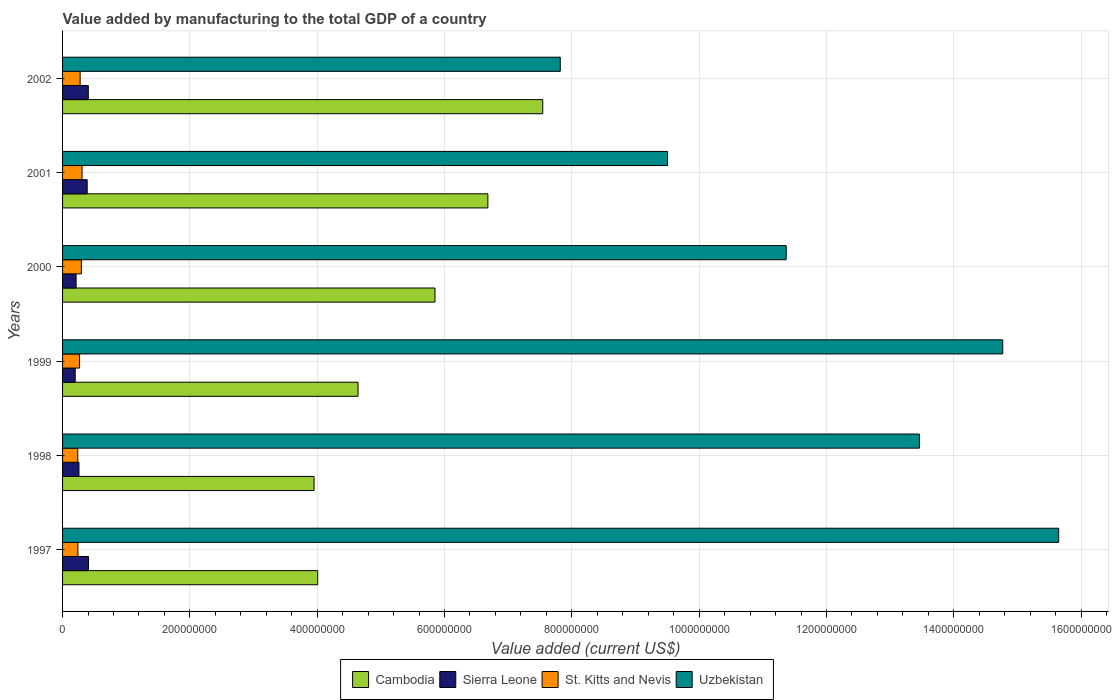How many different coloured bars are there?
Ensure brevity in your answer.  4. Are the number of bars per tick equal to the number of legend labels?
Provide a short and direct response. Yes. How many bars are there on the 4th tick from the top?
Make the answer very short. 4. What is the value added by manufacturing to the total GDP in St. Kitts and Nevis in 2002?
Make the answer very short. 2.76e+07. Across all years, what is the maximum value added by manufacturing to the total GDP in Uzbekistan?
Give a very brief answer. 1.56e+09. Across all years, what is the minimum value added by manufacturing to the total GDP in Uzbekistan?
Offer a very short reply. 7.82e+08. In which year was the value added by manufacturing to the total GDP in Uzbekistan maximum?
Make the answer very short. 1997. What is the total value added by manufacturing to the total GDP in Sierra Leone in the graph?
Provide a short and direct response. 1.87e+08. What is the difference between the value added by manufacturing to the total GDP in Cambodia in 2001 and that in 2002?
Offer a terse response. -8.62e+07. What is the difference between the value added by manufacturing to the total GDP in Sierra Leone in 1999 and the value added by manufacturing to the total GDP in Cambodia in 2001?
Give a very brief answer. -6.48e+08. What is the average value added by manufacturing to the total GDP in Uzbekistan per year?
Provide a short and direct response. 1.21e+09. In the year 1997, what is the difference between the value added by manufacturing to the total GDP in St. Kitts and Nevis and value added by manufacturing to the total GDP in Cambodia?
Your response must be concise. -3.77e+08. In how many years, is the value added by manufacturing to the total GDP in Cambodia greater than 1400000000 US$?
Provide a short and direct response. 0. What is the ratio of the value added by manufacturing to the total GDP in Sierra Leone in 1998 to that in 2002?
Make the answer very short. 0.64. What is the difference between the highest and the second highest value added by manufacturing to the total GDP in Cambodia?
Offer a terse response. 8.62e+07. What is the difference between the highest and the lowest value added by manufacturing to the total GDP in Cambodia?
Your answer should be very brief. 3.59e+08. What does the 1st bar from the top in 1998 represents?
Your answer should be compact. Uzbekistan. What does the 4th bar from the bottom in 1998 represents?
Keep it short and to the point. Uzbekistan. Is it the case that in every year, the sum of the value added by manufacturing to the total GDP in Sierra Leone and value added by manufacturing to the total GDP in Uzbekistan is greater than the value added by manufacturing to the total GDP in St. Kitts and Nevis?
Your response must be concise. Yes. How many bars are there?
Your answer should be compact. 24. Are all the bars in the graph horizontal?
Ensure brevity in your answer.  Yes. What is the difference between two consecutive major ticks on the X-axis?
Your answer should be compact. 2.00e+08. Are the values on the major ticks of X-axis written in scientific E-notation?
Provide a succinct answer. No. Does the graph contain any zero values?
Your answer should be compact. No. Does the graph contain grids?
Provide a short and direct response. Yes. How are the legend labels stacked?
Ensure brevity in your answer.  Horizontal. What is the title of the graph?
Ensure brevity in your answer.  Value added by manufacturing to the total GDP of a country. What is the label or title of the X-axis?
Your response must be concise. Value added (current US$). What is the label or title of the Y-axis?
Your answer should be very brief. Years. What is the Value added (current US$) in Cambodia in 1997?
Provide a short and direct response. 4.01e+08. What is the Value added (current US$) of Sierra Leone in 1997?
Keep it short and to the point. 4.07e+07. What is the Value added (current US$) of St. Kitts and Nevis in 1997?
Provide a succinct answer. 2.41e+07. What is the Value added (current US$) in Uzbekistan in 1997?
Provide a short and direct response. 1.56e+09. What is the Value added (current US$) in Cambodia in 1998?
Provide a succinct answer. 3.95e+08. What is the Value added (current US$) in Sierra Leone in 1998?
Your answer should be very brief. 2.58e+07. What is the Value added (current US$) in St. Kitts and Nevis in 1998?
Keep it short and to the point. 2.38e+07. What is the Value added (current US$) in Uzbekistan in 1998?
Keep it short and to the point. 1.35e+09. What is the Value added (current US$) of Cambodia in 1999?
Offer a very short reply. 4.64e+08. What is the Value added (current US$) in Sierra Leone in 1999?
Offer a very short reply. 1.99e+07. What is the Value added (current US$) in St. Kitts and Nevis in 1999?
Your answer should be compact. 2.67e+07. What is the Value added (current US$) of Uzbekistan in 1999?
Make the answer very short. 1.48e+09. What is the Value added (current US$) in Cambodia in 2000?
Your answer should be very brief. 5.85e+08. What is the Value added (current US$) of Sierra Leone in 2000?
Provide a short and direct response. 2.13e+07. What is the Value added (current US$) of St. Kitts and Nevis in 2000?
Provide a succinct answer. 2.95e+07. What is the Value added (current US$) of Uzbekistan in 2000?
Your response must be concise. 1.14e+09. What is the Value added (current US$) in Cambodia in 2001?
Your answer should be compact. 6.68e+08. What is the Value added (current US$) of Sierra Leone in 2001?
Ensure brevity in your answer.  3.87e+07. What is the Value added (current US$) in St. Kitts and Nevis in 2001?
Ensure brevity in your answer.  3.06e+07. What is the Value added (current US$) of Uzbekistan in 2001?
Offer a terse response. 9.50e+08. What is the Value added (current US$) of Cambodia in 2002?
Keep it short and to the point. 7.54e+08. What is the Value added (current US$) of Sierra Leone in 2002?
Your response must be concise. 4.04e+07. What is the Value added (current US$) in St. Kitts and Nevis in 2002?
Give a very brief answer. 2.76e+07. What is the Value added (current US$) of Uzbekistan in 2002?
Offer a very short reply. 7.82e+08. Across all years, what is the maximum Value added (current US$) of Cambodia?
Offer a very short reply. 7.54e+08. Across all years, what is the maximum Value added (current US$) in Sierra Leone?
Keep it short and to the point. 4.07e+07. Across all years, what is the maximum Value added (current US$) in St. Kitts and Nevis?
Keep it short and to the point. 3.06e+07. Across all years, what is the maximum Value added (current US$) in Uzbekistan?
Offer a very short reply. 1.56e+09. Across all years, what is the minimum Value added (current US$) of Cambodia?
Your answer should be compact. 3.95e+08. Across all years, what is the minimum Value added (current US$) of Sierra Leone?
Your answer should be very brief. 1.99e+07. Across all years, what is the minimum Value added (current US$) in St. Kitts and Nevis?
Give a very brief answer. 2.38e+07. Across all years, what is the minimum Value added (current US$) in Uzbekistan?
Make the answer very short. 7.82e+08. What is the total Value added (current US$) of Cambodia in the graph?
Your response must be concise. 3.27e+09. What is the total Value added (current US$) of Sierra Leone in the graph?
Ensure brevity in your answer.  1.87e+08. What is the total Value added (current US$) in St. Kitts and Nevis in the graph?
Keep it short and to the point. 1.62e+08. What is the total Value added (current US$) of Uzbekistan in the graph?
Offer a terse response. 7.26e+09. What is the difference between the Value added (current US$) in Cambodia in 1997 and that in 1998?
Offer a very short reply. 5.71e+06. What is the difference between the Value added (current US$) in Sierra Leone in 1997 and that in 1998?
Your answer should be compact. 1.50e+07. What is the difference between the Value added (current US$) in St. Kitts and Nevis in 1997 and that in 1998?
Keep it short and to the point. 2.63e+05. What is the difference between the Value added (current US$) of Uzbekistan in 1997 and that in 1998?
Give a very brief answer. 2.19e+08. What is the difference between the Value added (current US$) of Cambodia in 1997 and that in 1999?
Offer a terse response. -6.34e+07. What is the difference between the Value added (current US$) in Sierra Leone in 1997 and that in 1999?
Provide a succinct answer. 2.09e+07. What is the difference between the Value added (current US$) in St. Kitts and Nevis in 1997 and that in 1999?
Offer a very short reply. -2.59e+06. What is the difference between the Value added (current US$) in Uzbekistan in 1997 and that in 1999?
Your answer should be very brief. 8.79e+07. What is the difference between the Value added (current US$) of Cambodia in 1997 and that in 2000?
Keep it short and to the point. -1.84e+08. What is the difference between the Value added (current US$) of Sierra Leone in 1997 and that in 2000?
Your answer should be very brief. 1.95e+07. What is the difference between the Value added (current US$) in St. Kitts and Nevis in 1997 and that in 2000?
Provide a short and direct response. -5.41e+06. What is the difference between the Value added (current US$) in Uzbekistan in 1997 and that in 2000?
Keep it short and to the point. 4.28e+08. What is the difference between the Value added (current US$) in Cambodia in 1997 and that in 2001?
Your response must be concise. -2.67e+08. What is the difference between the Value added (current US$) of Sierra Leone in 1997 and that in 2001?
Keep it short and to the point. 2.05e+06. What is the difference between the Value added (current US$) of St. Kitts and Nevis in 1997 and that in 2001?
Give a very brief answer. -6.47e+06. What is the difference between the Value added (current US$) of Uzbekistan in 1997 and that in 2001?
Give a very brief answer. 6.14e+08. What is the difference between the Value added (current US$) in Cambodia in 1997 and that in 2002?
Offer a very short reply. -3.54e+08. What is the difference between the Value added (current US$) of Sierra Leone in 1997 and that in 2002?
Keep it short and to the point. 3.05e+05. What is the difference between the Value added (current US$) of St. Kitts and Nevis in 1997 and that in 2002?
Make the answer very short. -3.47e+06. What is the difference between the Value added (current US$) of Uzbekistan in 1997 and that in 2002?
Provide a succinct answer. 7.83e+08. What is the difference between the Value added (current US$) in Cambodia in 1998 and that in 1999?
Ensure brevity in your answer.  -6.91e+07. What is the difference between the Value added (current US$) of Sierra Leone in 1998 and that in 1999?
Your answer should be compact. 5.89e+06. What is the difference between the Value added (current US$) of St. Kitts and Nevis in 1998 and that in 1999?
Your response must be concise. -2.85e+06. What is the difference between the Value added (current US$) in Uzbekistan in 1998 and that in 1999?
Provide a short and direct response. -1.31e+08. What is the difference between the Value added (current US$) of Cambodia in 1998 and that in 2000?
Your answer should be compact. -1.90e+08. What is the difference between the Value added (current US$) in Sierra Leone in 1998 and that in 2000?
Give a very brief answer. 4.48e+06. What is the difference between the Value added (current US$) in St. Kitts and Nevis in 1998 and that in 2000?
Offer a terse response. -5.68e+06. What is the difference between the Value added (current US$) in Uzbekistan in 1998 and that in 2000?
Offer a terse response. 2.09e+08. What is the difference between the Value added (current US$) in Cambodia in 1998 and that in 2001?
Provide a succinct answer. -2.73e+08. What is the difference between the Value added (current US$) in Sierra Leone in 1998 and that in 2001?
Provide a short and direct response. -1.29e+07. What is the difference between the Value added (current US$) of St. Kitts and Nevis in 1998 and that in 2001?
Your answer should be very brief. -6.73e+06. What is the difference between the Value added (current US$) in Uzbekistan in 1998 and that in 2001?
Ensure brevity in your answer.  3.96e+08. What is the difference between the Value added (current US$) in Cambodia in 1998 and that in 2002?
Give a very brief answer. -3.59e+08. What is the difference between the Value added (current US$) of Sierra Leone in 1998 and that in 2002?
Your response must be concise. -1.47e+07. What is the difference between the Value added (current US$) of St. Kitts and Nevis in 1998 and that in 2002?
Give a very brief answer. -3.74e+06. What is the difference between the Value added (current US$) of Uzbekistan in 1998 and that in 2002?
Offer a terse response. 5.64e+08. What is the difference between the Value added (current US$) in Cambodia in 1999 and that in 2000?
Give a very brief answer. -1.21e+08. What is the difference between the Value added (current US$) of Sierra Leone in 1999 and that in 2000?
Offer a very short reply. -1.41e+06. What is the difference between the Value added (current US$) in St. Kitts and Nevis in 1999 and that in 2000?
Offer a very short reply. -2.83e+06. What is the difference between the Value added (current US$) of Uzbekistan in 1999 and that in 2000?
Keep it short and to the point. 3.40e+08. What is the difference between the Value added (current US$) in Cambodia in 1999 and that in 2001?
Your answer should be compact. -2.04e+08. What is the difference between the Value added (current US$) in Sierra Leone in 1999 and that in 2001?
Give a very brief answer. -1.88e+07. What is the difference between the Value added (current US$) in St. Kitts and Nevis in 1999 and that in 2001?
Your answer should be very brief. -3.88e+06. What is the difference between the Value added (current US$) in Uzbekistan in 1999 and that in 2001?
Offer a terse response. 5.27e+08. What is the difference between the Value added (current US$) in Cambodia in 1999 and that in 2002?
Give a very brief answer. -2.90e+08. What is the difference between the Value added (current US$) of Sierra Leone in 1999 and that in 2002?
Make the answer very short. -2.06e+07. What is the difference between the Value added (current US$) in St. Kitts and Nevis in 1999 and that in 2002?
Your response must be concise. -8.85e+05. What is the difference between the Value added (current US$) in Uzbekistan in 1999 and that in 2002?
Keep it short and to the point. 6.95e+08. What is the difference between the Value added (current US$) in Cambodia in 2000 and that in 2001?
Keep it short and to the point. -8.31e+07. What is the difference between the Value added (current US$) in Sierra Leone in 2000 and that in 2001?
Offer a terse response. -1.74e+07. What is the difference between the Value added (current US$) of St. Kitts and Nevis in 2000 and that in 2001?
Provide a short and direct response. -1.06e+06. What is the difference between the Value added (current US$) in Uzbekistan in 2000 and that in 2001?
Provide a succinct answer. 1.86e+08. What is the difference between the Value added (current US$) in Cambodia in 2000 and that in 2002?
Offer a very short reply. -1.69e+08. What is the difference between the Value added (current US$) in Sierra Leone in 2000 and that in 2002?
Make the answer very short. -1.91e+07. What is the difference between the Value added (current US$) in St. Kitts and Nevis in 2000 and that in 2002?
Your answer should be compact. 1.94e+06. What is the difference between the Value added (current US$) of Uzbekistan in 2000 and that in 2002?
Make the answer very short. 3.55e+08. What is the difference between the Value added (current US$) of Cambodia in 2001 and that in 2002?
Offer a very short reply. -8.62e+07. What is the difference between the Value added (current US$) in Sierra Leone in 2001 and that in 2002?
Ensure brevity in your answer.  -1.74e+06. What is the difference between the Value added (current US$) in St. Kitts and Nevis in 2001 and that in 2002?
Offer a terse response. 3.00e+06. What is the difference between the Value added (current US$) of Uzbekistan in 2001 and that in 2002?
Your answer should be very brief. 1.69e+08. What is the difference between the Value added (current US$) of Cambodia in 1997 and the Value added (current US$) of Sierra Leone in 1998?
Offer a very short reply. 3.75e+08. What is the difference between the Value added (current US$) of Cambodia in 1997 and the Value added (current US$) of St. Kitts and Nevis in 1998?
Provide a short and direct response. 3.77e+08. What is the difference between the Value added (current US$) of Cambodia in 1997 and the Value added (current US$) of Uzbekistan in 1998?
Give a very brief answer. -9.45e+08. What is the difference between the Value added (current US$) in Sierra Leone in 1997 and the Value added (current US$) in St. Kitts and Nevis in 1998?
Your answer should be compact. 1.69e+07. What is the difference between the Value added (current US$) of Sierra Leone in 1997 and the Value added (current US$) of Uzbekistan in 1998?
Offer a very short reply. -1.31e+09. What is the difference between the Value added (current US$) of St. Kitts and Nevis in 1997 and the Value added (current US$) of Uzbekistan in 1998?
Your answer should be very brief. -1.32e+09. What is the difference between the Value added (current US$) in Cambodia in 1997 and the Value added (current US$) in Sierra Leone in 1999?
Your response must be concise. 3.81e+08. What is the difference between the Value added (current US$) of Cambodia in 1997 and the Value added (current US$) of St. Kitts and Nevis in 1999?
Offer a very short reply. 3.74e+08. What is the difference between the Value added (current US$) in Cambodia in 1997 and the Value added (current US$) in Uzbekistan in 1999?
Offer a very short reply. -1.08e+09. What is the difference between the Value added (current US$) of Sierra Leone in 1997 and the Value added (current US$) of St. Kitts and Nevis in 1999?
Your answer should be very brief. 1.40e+07. What is the difference between the Value added (current US$) of Sierra Leone in 1997 and the Value added (current US$) of Uzbekistan in 1999?
Your answer should be compact. -1.44e+09. What is the difference between the Value added (current US$) of St. Kitts and Nevis in 1997 and the Value added (current US$) of Uzbekistan in 1999?
Provide a succinct answer. -1.45e+09. What is the difference between the Value added (current US$) in Cambodia in 1997 and the Value added (current US$) in Sierra Leone in 2000?
Offer a terse response. 3.80e+08. What is the difference between the Value added (current US$) of Cambodia in 1997 and the Value added (current US$) of St. Kitts and Nevis in 2000?
Keep it short and to the point. 3.71e+08. What is the difference between the Value added (current US$) of Cambodia in 1997 and the Value added (current US$) of Uzbekistan in 2000?
Provide a short and direct response. -7.36e+08. What is the difference between the Value added (current US$) in Sierra Leone in 1997 and the Value added (current US$) in St. Kitts and Nevis in 2000?
Keep it short and to the point. 1.12e+07. What is the difference between the Value added (current US$) of Sierra Leone in 1997 and the Value added (current US$) of Uzbekistan in 2000?
Offer a very short reply. -1.10e+09. What is the difference between the Value added (current US$) in St. Kitts and Nevis in 1997 and the Value added (current US$) in Uzbekistan in 2000?
Offer a very short reply. -1.11e+09. What is the difference between the Value added (current US$) in Cambodia in 1997 and the Value added (current US$) in Sierra Leone in 2001?
Ensure brevity in your answer.  3.62e+08. What is the difference between the Value added (current US$) in Cambodia in 1997 and the Value added (current US$) in St. Kitts and Nevis in 2001?
Keep it short and to the point. 3.70e+08. What is the difference between the Value added (current US$) of Cambodia in 1997 and the Value added (current US$) of Uzbekistan in 2001?
Keep it short and to the point. -5.50e+08. What is the difference between the Value added (current US$) in Sierra Leone in 1997 and the Value added (current US$) in St. Kitts and Nevis in 2001?
Give a very brief answer. 1.02e+07. What is the difference between the Value added (current US$) in Sierra Leone in 1997 and the Value added (current US$) in Uzbekistan in 2001?
Keep it short and to the point. -9.10e+08. What is the difference between the Value added (current US$) of St. Kitts and Nevis in 1997 and the Value added (current US$) of Uzbekistan in 2001?
Offer a very short reply. -9.26e+08. What is the difference between the Value added (current US$) in Cambodia in 1997 and the Value added (current US$) in Sierra Leone in 2002?
Provide a succinct answer. 3.60e+08. What is the difference between the Value added (current US$) in Cambodia in 1997 and the Value added (current US$) in St. Kitts and Nevis in 2002?
Ensure brevity in your answer.  3.73e+08. What is the difference between the Value added (current US$) in Cambodia in 1997 and the Value added (current US$) in Uzbekistan in 2002?
Offer a very short reply. -3.81e+08. What is the difference between the Value added (current US$) in Sierra Leone in 1997 and the Value added (current US$) in St. Kitts and Nevis in 2002?
Offer a terse response. 1.31e+07. What is the difference between the Value added (current US$) of Sierra Leone in 1997 and the Value added (current US$) of Uzbekistan in 2002?
Make the answer very short. -7.41e+08. What is the difference between the Value added (current US$) of St. Kitts and Nevis in 1997 and the Value added (current US$) of Uzbekistan in 2002?
Provide a short and direct response. -7.58e+08. What is the difference between the Value added (current US$) of Cambodia in 1998 and the Value added (current US$) of Sierra Leone in 1999?
Offer a very short reply. 3.75e+08. What is the difference between the Value added (current US$) of Cambodia in 1998 and the Value added (current US$) of St. Kitts and Nevis in 1999?
Your answer should be very brief. 3.68e+08. What is the difference between the Value added (current US$) of Cambodia in 1998 and the Value added (current US$) of Uzbekistan in 1999?
Give a very brief answer. -1.08e+09. What is the difference between the Value added (current US$) in Sierra Leone in 1998 and the Value added (current US$) in St. Kitts and Nevis in 1999?
Provide a short and direct response. -9.41e+05. What is the difference between the Value added (current US$) in Sierra Leone in 1998 and the Value added (current US$) in Uzbekistan in 1999?
Offer a terse response. -1.45e+09. What is the difference between the Value added (current US$) in St. Kitts and Nevis in 1998 and the Value added (current US$) in Uzbekistan in 1999?
Your answer should be compact. -1.45e+09. What is the difference between the Value added (current US$) of Cambodia in 1998 and the Value added (current US$) of Sierra Leone in 2000?
Give a very brief answer. 3.74e+08. What is the difference between the Value added (current US$) of Cambodia in 1998 and the Value added (current US$) of St. Kitts and Nevis in 2000?
Offer a terse response. 3.66e+08. What is the difference between the Value added (current US$) of Cambodia in 1998 and the Value added (current US$) of Uzbekistan in 2000?
Give a very brief answer. -7.42e+08. What is the difference between the Value added (current US$) in Sierra Leone in 1998 and the Value added (current US$) in St. Kitts and Nevis in 2000?
Provide a succinct answer. -3.77e+06. What is the difference between the Value added (current US$) in Sierra Leone in 1998 and the Value added (current US$) in Uzbekistan in 2000?
Ensure brevity in your answer.  -1.11e+09. What is the difference between the Value added (current US$) of St. Kitts and Nevis in 1998 and the Value added (current US$) of Uzbekistan in 2000?
Provide a short and direct response. -1.11e+09. What is the difference between the Value added (current US$) in Cambodia in 1998 and the Value added (current US$) in Sierra Leone in 2001?
Offer a very short reply. 3.56e+08. What is the difference between the Value added (current US$) of Cambodia in 1998 and the Value added (current US$) of St. Kitts and Nevis in 2001?
Ensure brevity in your answer.  3.65e+08. What is the difference between the Value added (current US$) of Cambodia in 1998 and the Value added (current US$) of Uzbekistan in 2001?
Ensure brevity in your answer.  -5.55e+08. What is the difference between the Value added (current US$) in Sierra Leone in 1998 and the Value added (current US$) in St. Kitts and Nevis in 2001?
Offer a very short reply. -4.82e+06. What is the difference between the Value added (current US$) in Sierra Leone in 1998 and the Value added (current US$) in Uzbekistan in 2001?
Provide a short and direct response. -9.25e+08. What is the difference between the Value added (current US$) of St. Kitts and Nevis in 1998 and the Value added (current US$) of Uzbekistan in 2001?
Provide a short and direct response. -9.27e+08. What is the difference between the Value added (current US$) of Cambodia in 1998 and the Value added (current US$) of Sierra Leone in 2002?
Give a very brief answer. 3.55e+08. What is the difference between the Value added (current US$) of Cambodia in 1998 and the Value added (current US$) of St. Kitts and Nevis in 2002?
Your response must be concise. 3.68e+08. What is the difference between the Value added (current US$) of Cambodia in 1998 and the Value added (current US$) of Uzbekistan in 2002?
Keep it short and to the point. -3.87e+08. What is the difference between the Value added (current US$) in Sierra Leone in 1998 and the Value added (current US$) in St. Kitts and Nevis in 2002?
Your response must be concise. -1.83e+06. What is the difference between the Value added (current US$) in Sierra Leone in 1998 and the Value added (current US$) in Uzbekistan in 2002?
Your response must be concise. -7.56e+08. What is the difference between the Value added (current US$) of St. Kitts and Nevis in 1998 and the Value added (current US$) of Uzbekistan in 2002?
Provide a succinct answer. -7.58e+08. What is the difference between the Value added (current US$) of Cambodia in 1999 and the Value added (current US$) of Sierra Leone in 2000?
Make the answer very short. 4.43e+08. What is the difference between the Value added (current US$) in Cambodia in 1999 and the Value added (current US$) in St. Kitts and Nevis in 2000?
Provide a short and direct response. 4.35e+08. What is the difference between the Value added (current US$) of Cambodia in 1999 and the Value added (current US$) of Uzbekistan in 2000?
Your answer should be compact. -6.73e+08. What is the difference between the Value added (current US$) of Sierra Leone in 1999 and the Value added (current US$) of St. Kitts and Nevis in 2000?
Provide a short and direct response. -9.65e+06. What is the difference between the Value added (current US$) of Sierra Leone in 1999 and the Value added (current US$) of Uzbekistan in 2000?
Provide a short and direct response. -1.12e+09. What is the difference between the Value added (current US$) in St. Kitts and Nevis in 1999 and the Value added (current US$) in Uzbekistan in 2000?
Make the answer very short. -1.11e+09. What is the difference between the Value added (current US$) of Cambodia in 1999 and the Value added (current US$) of Sierra Leone in 2001?
Your response must be concise. 4.25e+08. What is the difference between the Value added (current US$) in Cambodia in 1999 and the Value added (current US$) in St. Kitts and Nevis in 2001?
Your answer should be compact. 4.34e+08. What is the difference between the Value added (current US$) in Cambodia in 1999 and the Value added (current US$) in Uzbekistan in 2001?
Provide a succinct answer. -4.86e+08. What is the difference between the Value added (current US$) in Sierra Leone in 1999 and the Value added (current US$) in St. Kitts and Nevis in 2001?
Give a very brief answer. -1.07e+07. What is the difference between the Value added (current US$) in Sierra Leone in 1999 and the Value added (current US$) in Uzbekistan in 2001?
Your answer should be very brief. -9.30e+08. What is the difference between the Value added (current US$) of St. Kitts and Nevis in 1999 and the Value added (current US$) of Uzbekistan in 2001?
Offer a terse response. -9.24e+08. What is the difference between the Value added (current US$) in Cambodia in 1999 and the Value added (current US$) in Sierra Leone in 2002?
Keep it short and to the point. 4.24e+08. What is the difference between the Value added (current US$) in Cambodia in 1999 and the Value added (current US$) in St. Kitts and Nevis in 2002?
Your response must be concise. 4.37e+08. What is the difference between the Value added (current US$) of Cambodia in 1999 and the Value added (current US$) of Uzbekistan in 2002?
Offer a terse response. -3.18e+08. What is the difference between the Value added (current US$) in Sierra Leone in 1999 and the Value added (current US$) in St. Kitts and Nevis in 2002?
Keep it short and to the point. -7.71e+06. What is the difference between the Value added (current US$) of Sierra Leone in 1999 and the Value added (current US$) of Uzbekistan in 2002?
Provide a short and direct response. -7.62e+08. What is the difference between the Value added (current US$) in St. Kitts and Nevis in 1999 and the Value added (current US$) in Uzbekistan in 2002?
Provide a short and direct response. -7.55e+08. What is the difference between the Value added (current US$) in Cambodia in 2000 and the Value added (current US$) in Sierra Leone in 2001?
Your answer should be compact. 5.46e+08. What is the difference between the Value added (current US$) in Cambodia in 2000 and the Value added (current US$) in St. Kitts and Nevis in 2001?
Keep it short and to the point. 5.54e+08. What is the difference between the Value added (current US$) of Cambodia in 2000 and the Value added (current US$) of Uzbekistan in 2001?
Provide a short and direct response. -3.65e+08. What is the difference between the Value added (current US$) in Sierra Leone in 2000 and the Value added (current US$) in St. Kitts and Nevis in 2001?
Keep it short and to the point. -9.30e+06. What is the difference between the Value added (current US$) in Sierra Leone in 2000 and the Value added (current US$) in Uzbekistan in 2001?
Provide a short and direct response. -9.29e+08. What is the difference between the Value added (current US$) of St. Kitts and Nevis in 2000 and the Value added (current US$) of Uzbekistan in 2001?
Your answer should be very brief. -9.21e+08. What is the difference between the Value added (current US$) of Cambodia in 2000 and the Value added (current US$) of Sierra Leone in 2002?
Your response must be concise. 5.45e+08. What is the difference between the Value added (current US$) in Cambodia in 2000 and the Value added (current US$) in St. Kitts and Nevis in 2002?
Offer a very short reply. 5.57e+08. What is the difference between the Value added (current US$) in Cambodia in 2000 and the Value added (current US$) in Uzbekistan in 2002?
Provide a short and direct response. -1.97e+08. What is the difference between the Value added (current US$) in Sierra Leone in 2000 and the Value added (current US$) in St. Kitts and Nevis in 2002?
Make the answer very short. -6.30e+06. What is the difference between the Value added (current US$) of Sierra Leone in 2000 and the Value added (current US$) of Uzbekistan in 2002?
Keep it short and to the point. -7.61e+08. What is the difference between the Value added (current US$) of St. Kitts and Nevis in 2000 and the Value added (current US$) of Uzbekistan in 2002?
Your answer should be very brief. -7.52e+08. What is the difference between the Value added (current US$) of Cambodia in 2001 and the Value added (current US$) of Sierra Leone in 2002?
Offer a very short reply. 6.28e+08. What is the difference between the Value added (current US$) in Cambodia in 2001 and the Value added (current US$) in St. Kitts and Nevis in 2002?
Make the answer very short. 6.41e+08. What is the difference between the Value added (current US$) in Cambodia in 2001 and the Value added (current US$) in Uzbekistan in 2002?
Your response must be concise. -1.14e+08. What is the difference between the Value added (current US$) of Sierra Leone in 2001 and the Value added (current US$) of St. Kitts and Nevis in 2002?
Give a very brief answer. 1.11e+07. What is the difference between the Value added (current US$) in Sierra Leone in 2001 and the Value added (current US$) in Uzbekistan in 2002?
Offer a very short reply. -7.43e+08. What is the difference between the Value added (current US$) of St. Kitts and Nevis in 2001 and the Value added (current US$) of Uzbekistan in 2002?
Provide a succinct answer. -7.51e+08. What is the average Value added (current US$) in Cambodia per year?
Your answer should be compact. 5.45e+08. What is the average Value added (current US$) of Sierra Leone per year?
Ensure brevity in your answer.  3.11e+07. What is the average Value added (current US$) in St. Kitts and Nevis per year?
Give a very brief answer. 2.71e+07. What is the average Value added (current US$) in Uzbekistan per year?
Provide a succinct answer. 1.21e+09. In the year 1997, what is the difference between the Value added (current US$) in Cambodia and Value added (current US$) in Sierra Leone?
Your answer should be very brief. 3.60e+08. In the year 1997, what is the difference between the Value added (current US$) of Cambodia and Value added (current US$) of St. Kitts and Nevis?
Offer a very short reply. 3.77e+08. In the year 1997, what is the difference between the Value added (current US$) of Cambodia and Value added (current US$) of Uzbekistan?
Offer a very short reply. -1.16e+09. In the year 1997, what is the difference between the Value added (current US$) in Sierra Leone and Value added (current US$) in St. Kitts and Nevis?
Keep it short and to the point. 1.66e+07. In the year 1997, what is the difference between the Value added (current US$) in Sierra Leone and Value added (current US$) in Uzbekistan?
Offer a very short reply. -1.52e+09. In the year 1997, what is the difference between the Value added (current US$) of St. Kitts and Nevis and Value added (current US$) of Uzbekistan?
Your answer should be compact. -1.54e+09. In the year 1998, what is the difference between the Value added (current US$) in Cambodia and Value added (current US$) in Sierra Leone?
Provide a short and direct response. 3.69e+08. In the year 1998, what is the difference between the Value added (current US$) of Cambodia and Value added (current US$) of St. Kitts and Nevis?
Give a very brief answer. 3.71e+08. In the year 1998, what is the difference between the Value added (current US$) in Cambodia and Value added (current US$) in Uzbekistan?
Provide a short and direct response. -9.51e+08. In the year 1998, what is the difference between the Value added (current US$) of Sierra Leone and Value added (current US$) of St. Kitts and Nevis?
Keep it short and to the point. 1.91e+06. In the year 1998, what is the difference between the Value added (current US$) of Sierra Leone and Value added (current US$) of Uzbekistan?
Offer a terse response. -1.32e+09. In the year 1998, what is the difference between the Value added (current US$) in St. Kitts and Nevis and Value added (current US$) in Uzbekistan?
Offer a very short reply. -1.32e+09. In the year 1999, what is the difference between the Value added (current US$) in Cambodia and Value added (current US$) in Sierra Leone?
Offer a terse response. 4.44e+08. In the year 1999, what is the difference between the Value added (current US$) of Cambodia and Value added (current US$) of St. Kitts and Nevis?
Ensure brevity in your answer.  4.37e+08. In the year 1999, what is the difference between the Value added (current US$) in Cambodia and Value added (current US$) in Uzbekistan?
Give a very brief answer. -1.01e+09. In the year 1999, what is the difference between the Value added (current US$) of Sierra Leone and Value added (current US$) of St. Kitts and Nevis?
Ensure brevity in your answer.  -6.83e+06. In the year 1999, what is the difference between the Value added (current US$) of Sierra Leone and Value added (current US$) of Uzbekistan?
Give a very brief answer. -1.46e+09. In the year 1999, what is the difference between the Value added (current US$) of St. Kitts and Nevis and Value added (current US$) of Uzbekistan?
Make the answer very short. -1.45e+09. In the year 2000, what is the difference between the Value added (current US$) in Cambodia and Value added (current US$) in Sierra Leone?
Your answer should be compact. 5.64e+08. In the year 2000, what is the difference between the Value added (current US$) of Cambodia and Value added (current US$) of St. Kitts and Nevis?
Give a very brief answer. 5.56e+08. In the year 2000, what is the difference between the Value added (current US$) of Cambodia and Value added (current US$) of Uzbekistan?
Your response must be concise. -5.52e+08. In the year 2000, what is the difference between the Value added (current US$) of Sierra Leone and Value added (current US$) of St. Kitts and Nevis?
Your response must be concise. -8.24e+06. In the year 2000, what is the difference between the Value added (current US$) of Sierra Leone and Value added (current US$) of Uzbekistan?
Keep it short and to the point. -1.12e+09. In the year 2000, what is the difference between the Value added (current US$) of St. Kitts and Nevis and Value added (current US$) of Uzbekistan?
Your answer should be compact. -1.11e+09. In the year 2001, what is the difference between the Value added (current US$) in Cambodia and Value added (current US$) in Sierra Leone?
Your response must be concise. 6.29e+08. In the year 2001, what is the difference between the Value added (current US$) in Cambodia and Value added (current US$) in St. Kitts and Nevis?
Offer a terse response. 6.38e+08. In the year 2001, what is the difference between the Value added (current US$) of Cambodia and Value added (current US$) of Uzbekistan?
Make the answer very short. -2.82e+08. In the year 2001, what is the difference between the Value added (current US$) in Sierra Leone and Value added (current US$) in St. Kitts and Nevis?
Make the answer very short. 8.11e+06. In the year 2001, what is the difference between the Value added (current US$) in Sierra Leone and Value added (current US$) in Uzbekistan?
Your response must be concise. -9.12e+08. In the year 2001, what is the difference between the Value added (current US$) in St. Kitts and Nevis and Value added (current US$) in Uzbekistan?
Offer a terse response. -9.20e+08. In the year 2002, what is the difference between the Value added (current US$) of Cambodia and Value added (current US$) of Sierra Leone?
Your answer should be compact. 7.14e+08. In the year 2002, what is the difference between the Value added (current US$) of Cambodia and Value added (current US$) of St. Kitts and Nevis?
Your response must be concise. 7.27e+08. In the year 2002, what is the difference between the Value added (current US$) in Cambodia and Value added (current US$) in Uzbekistan?
Your answer should be very brief. -2.75e+07. In the year 2002, what is the difference between the Value added (current US$) in Sierra Leone and Value added (current US$) in St. Kitts and Nevis?
Keep it short and to the point. 1.28e+07. In the year 2002, what is the difference between the Value added (current US$) in Sierra Leone and Value added (current US$) in Uzbekistan?
Ensure brevity in your answer.  -7.41e+08. In the year 2002, what is the difference between the Value added (current US$) in St. Kitts and Nevis and Value added (current US$) in Uzbekistan?
Your response must be concise. -7.54e+08. What is the ratio of the Value added (current US$) in Cambodia in 1997 to that in 1998?
Your answer should be very brief. 1.01. What is the ratio of the Value added (current US$) of Sierra Leone in 1997 to that in 1998?
Offer a very short reply. 1.58. What is the ratio of the Value added (current US$) in St. Kitts and Nevis in 1997 to that in 1998?
Keep it short and to the point. 1.01. What is the ratio of the Value added (current US$) of Uzbekistan in 1997 to that in 1998?
Give a very brief answer. 1.16. What is the ratio of the Value added (current US$) in Cambodia in 1997 to that in 1999?
Give a very brief answer. 0.86. What is the ratio of the Value added (current US$) in Sierra Leone in 1997 to that in 1999?
Keep it short and to the point. 2.05. What is the ratio of the Value added (current US$) in St. Kitts and Nevis in 1997 to that in 1999?
Offer a very short reply. 0.9. What is the ratio of the Value added (current US$) of Uzbekistan in 1997 to that in 1999?
Your response must be concise. 1.06. What is the ratio of the Value added (current US$) in Cambodia in 1997 to that in 2000?
Your answer should be compact. 0.69. What is the ratio of the Value added (current US$) in Sierra Leone in 1997 to that in 2000?
Offer a very short reply. 1.91. What is the ratio of the Value added (current US$) of St. Kitts and Nevis in 1997 to that in 2000?
Ensure brevity in your answer.  0.82. What is the ratio of the Value added (current US$) of Uzbekistan in 1997 to that in 2000?
Your answer should be compact. 1.38. What is the ratio of the Value added (current US$) of Cambodia in 1997 to that in 2001?
Give a very brief answer. 0.6. What is the ratio of the Value added (current US$) in Sierra Leone in 1997 to that in 2001?
Your response must be concise. 1.05. What is the ratio of the Value added (current US$) of St. Kitts and Nevis in 1997 to that in 2001?
Your answer should be very brief. 0.79. What is the ratio of the Value added (current US$) of Uzbekistan in 1997 to that in 2001?
Make the answer very short. 1.65. What is the ratio of the Value added (current US$) in Cambodia in 1997 to that in 2002?
Your answer should be very brief. 0.53. What is the ratio of the Value added (current US$) in Sierra Leone in 1997 to that in 2002?
Provide a short and direct response. 1.01. What is the ratio of the Value added (current US$) in St. Kitts and Nevis in 1997 to that in 2002?
Your response must be concise. 0.87. What is the ratio of the Value added (current US$) of Uzbekistan in 1997 to that in 2002?
Keep it short and to the point. 2. What is the ratio of the Value added (current US$) of Cambodia in 1998 to that in 1999?
Keep it short and to the point. 0.85. What is the ratio of the Value added (current US$) of Sierra Leone in 1998 to that in 1999?
Offer a terse response. 1.3. What is the ratio of the Value added (current US$) of St. Kitts and Nevis in 1998 to that in 1999?
Your response must be concise. 0.89. What is the ratio of the Value added (current US$) in Uzbekistan in 1998 to that in 1999?
Your answer should be compact. 0.91. What is the ratio of the Value added (current US$) in Cambodia in 1998 to that in 2000?
Ensure brevity in your answer.  0.68. What is the ratio of the Value added (current US$) of Sierra Leone in 1998 to that in 2000?
Keep it short and to the point. 1.21. What is the ratio of the Value added (current US$) in St. Kitts and Nevis in 1998 to that in 2000?
Your response must be concise. 0.81. What is the ratio of the Value added (current US$) of Uzbekistan in 1998 to that in 2000?
Provide a succinct answer. 1.18. What is the ratio of the Value added (current US$) in Cambodia in 1998 to that in 2001?
Give a very brief answer. 0.59. What is the ratio of the Value added (current US$) of Sierra Leone in 1998 to that in 2001?
Ensure brevity in your answer.  0.67. What is the ratio of the Value added (current US$) in St. Kitts and Nevis in 1998 to that in 2001?
Ensure brevity in your answer.  0.78. What is the ratio of the Value added (current US$) of Uzbekistan in 1998 to that in 2001?
Your answer should be compact. 1.42. What is the ratio of the Value added (current US$) of Cambodia in 1998 to that in 2002?
Keep it short and to the point. 0.52. What is the ratio of the Value added (current US$) in Sierra Leone in 1998 to that in 2002?
Provide a succinct answer. 0.64. What is the ratio of the Value added (current US$) of St. Kitts and Nevis in 1998 to that in 2002?
Provide a short and direct response. 0.86. What is the ratio of the Value added (current US$) of Uzbekistan in 1998 to that in 2002?
Give a very brief answer. 1.72. What is the ratio of the Value added (current US$) in Cambodia in 1999 to that in 2000?
Give a very brief answer. 0.79. What is the ratio of the Value added (current US$) of Sierra Leone in 1999 to that in 2000?
Keep it short and to the point. 0.93. What is the ratio of the Value added (current US$) in St. Kitts and Nevis in 1999 to that in 2000?
Your answer should be compact. 0.9. What is the ratio of the Value added (current US$) in Uzbekistan in 1999 to that in 2000?
Your answer should be very brief. 1.3. What is the ratio of the Value added (current US$) in Cambodia in 1999 to that in 2001?
Provide a short and direct response. 0.69. What is the ratio of the Value added (current US$) in Sierra Leone in 1999 to that in 2001?
Your response must be concise. 0.51. What is the ratio of the Value added (current US$) in St. Kitts and Nevis in 1999 to that in 2001?
Give a very brief answer. 0.87. What is the ratio of the Value added (current US$) in Uzbekistan in 1999 to that in 2001?
Offer a terse response. 1.55. What is the ratio of the Value added (current US$) of Cambodia in 1999 to that in 2002?
Your answer should be compact. 0.62. What is the ratio of the Value added (current US$) of Sierra Leone in 1999 to that in 2002?
Your answer should be compact. 0.49. What is the ratio of the Value added (current US$) in St. Kitts and Nevis in 1999 to that in 2002?
Ensure brevity in your answer.  0.97. What is the ratio of the Value added (current US$) of Uzbekistan in 1999 to that in 2002?
Offer a very short reply. 1.89. What is the ratio of the Value added (current US$) in Cambodia in 2000 to that in 2001?
Offer a terse response. 0.88. What is the ratio of the Value added (current US$) in Sierra Leone in 2000 to that in 2001?
Ensure brevity in your answer.  0.55. What is the ratio of the Value added (current US$) in St. Kitts and Nevis in 2000 to that in 2001?
Your answer should be very brief. 0.97. What is the ratio of the Value added (current US$) of Uzbekistan in 2000 to that in 2001?
Your answer should be compact. 1.2. What is the ratio of the Value added (current US$) in Cambodia in 2000 to that in 2002?
Make the answer very short. 0.78. What is the ratio of the Value added (current US$) in Sierra Leone in 2000 to that in 2002?
Your answer should be compact. 0.53. What is the ratio of the Value added (current US$) in St. Kitts and Nevis in 2000 to that in 2002?
Offer a very short reply. 1.07. What is the ratio of the Value added (current US$) in Uzbekistan in 2000 to that in 2002?
Ensure brevity in your answer.  1.45. What is the ratio of the Value added (current US$) of Cambodia in 2001 to that in 2002?
Make the answer very short. 0.89. What is the ratio of the Value added (current US$) in Sierra Leone in 2001 to that in 2002?
Provide a succinct answer. 0.96. What is the ratio of the Value added (current US$) in St. Kitts and Nevis in 2001 to that in 2002?
Give a very brief answer. 1.11. What is the ratio of the Value added (current US$) in Uzbekistan in 2001 to that in 2002?
Your answer should be very brief. 1.22. What is the difference between the highest and the second highest Value added (current US$) in Cambodia?
Your response must be concise. 8.62e+07. What is the difference between the highest and the second highest Value added (current US$) of Sierra Leone?
Give a very brief answer. 3.05e+05. What is the difference between the highest and the second highest Value added (current US$) in St. Kitts and Nevis?
Offer a very short reply. 1.06e+06. What is the difference between the highest and the second highest Value added (current US$) of Uzbekistan?
Your answer should be very brief. 8.79e+07. What is the difference between the highest and the lowest Value added (current US$) in Cambodia?
Make the answer very short. 3.59e+08. What is the difference between the highest and the lowest Value added (current US$) in Sierra Leone?
Provide a succinct answer. 2.09e+07. What is the difference between the highest and the lowest Value added (current US$) of St. Kitts and Nevis?
Your response must be concise. 6.73e+06. What is the difference between the highest and the lowest Value added (current US$) of Uzbekistan?
Keep it short and to the point. 7.83e+08. 